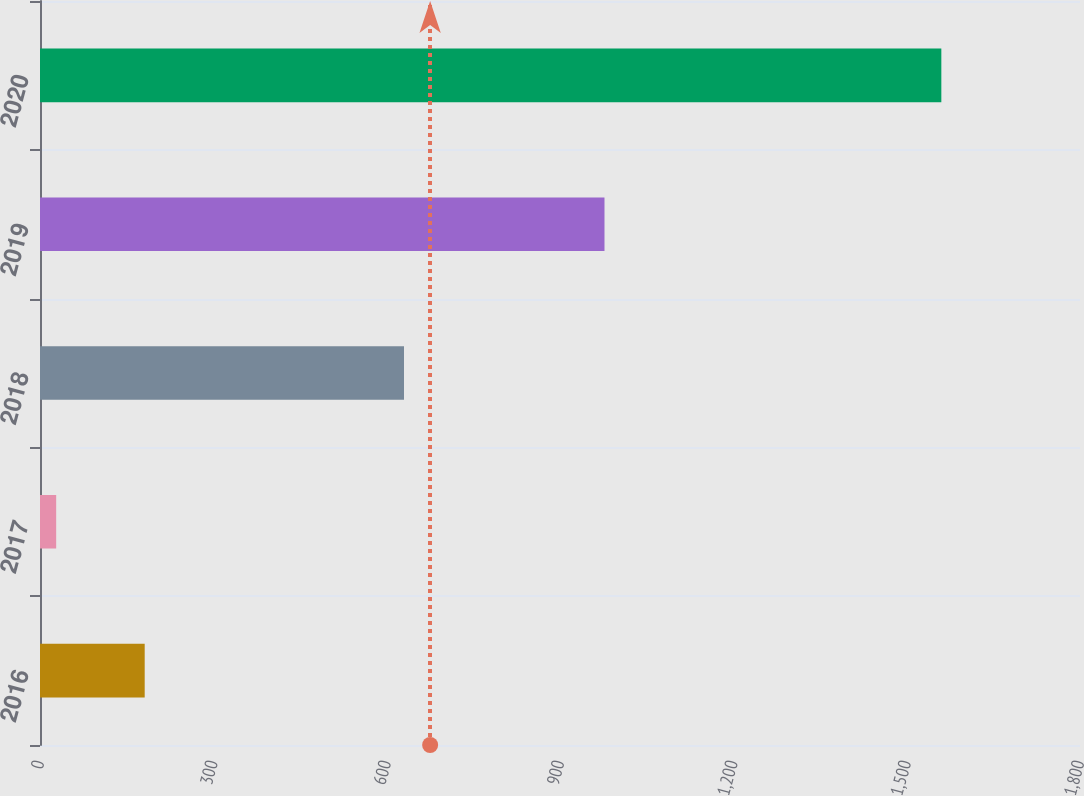Convert chart to OTSL. <chart><loc_0><loc_0><loc_500><loc_500><bar_chart><fcel>2016<fcel>2017<fcel>2018<fcel>2019<fcel>2020<nl><fcel>181.2<fcel>28<fcel>630<fcel>977<fcel>1560<nl></chart> 